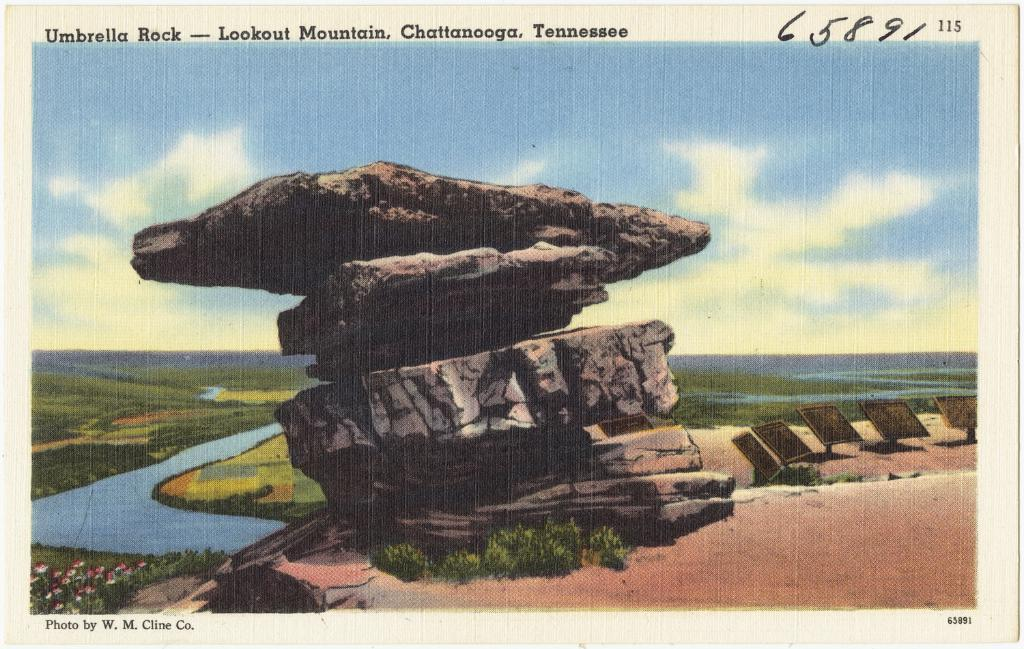What is the main subject of the painting in the image? The painting depicts a rock, grass, a fence, flowering plants, water, mountains, and the sky. What type of vegetation is depicted in the painting? The painting depicts grass and flowering plants. What type of natural feature is depicted in the painting? The painting depicts mountains. What is the weather condition depicted in the painting? The image appears to have been taken during the day, but there is no specific weather condition mentioned. Is there any text visible in the image? Yes, there is text visible at the top of the image. What type of industrial machinery can be seen in the painting? There is no industrial machinery present in the painting; it depicts natural elements such as a rock, grass, a fence, flowering plants, water, mountains, and the sky. What type of road can be seen in the painting? There is no road depicted in the painting; it focuses on natural elements and does not include any man-made structures. 